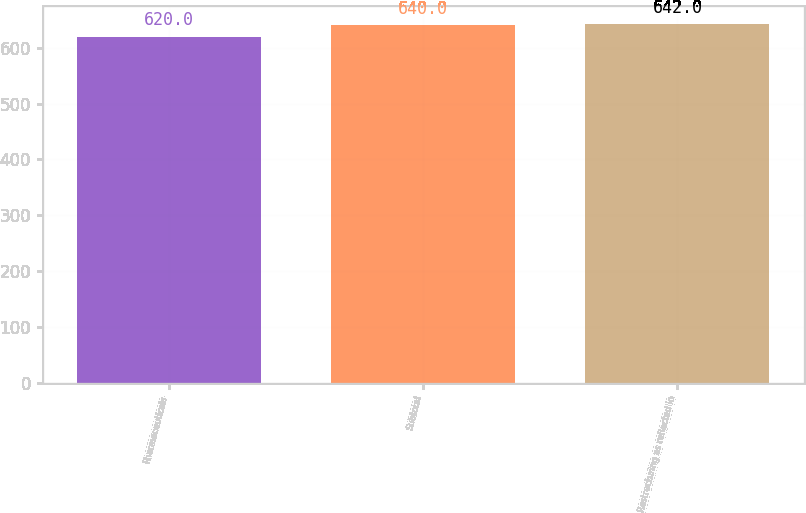Convert chart to OTSL. <chart><loc_0><loc_0><loc_500><loc_500><bar_chart><fcel>Pharmaceuticals<fcel>Subtotal<fcel>Restructuring as reflected in<nl><fcel>620<fcel>640<fcel>642<nl></chart> 